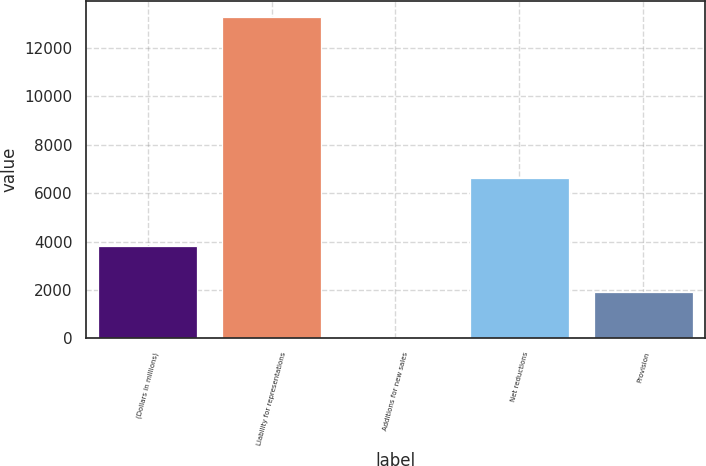<chart> <loc_0><loc_0><loc_500><loc_500><bar_chart><fcel>(Dollars in millions)<fcel>Liability for representations<fcel>Additions for new sales<fcel>Net reductions<fcel>Provision<nl><fcel>3833<fcel>13282<fcel>36<fcel>6615<fcel>1934.5<nl></chart> 